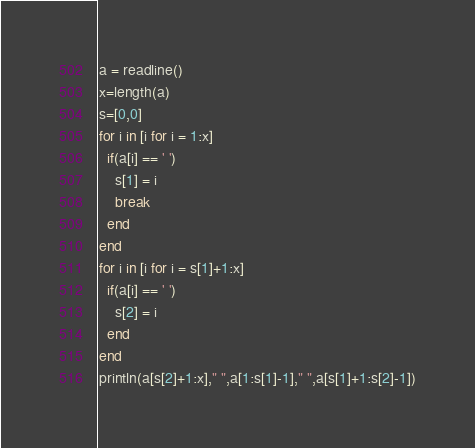<code> <loc_0><loc_0><loc_500><loc_500><_Julia_>a = readline()
x=length(a)
s=[0,0]
for i in [i for i = 1:x]
  if(a[i] == ' ')
  	s[1] = i
    break
  end
end
for i in [i for i = s[1]+1:x]
  if(a[i] == ' ')
  	s[2] = i
  end
end
println(a[s[2]+1:x]," ",a[1:s[1]-1]," ",a[s[1]+1:s[2]-1])</code> 